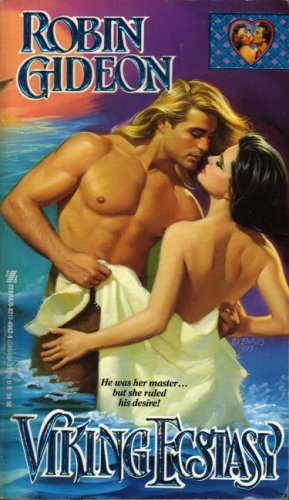Is this a sci-fi book? No, this book is not a sci-fi. It is a romance novel as indicated by its title and the illustrative artwork on its cover. 